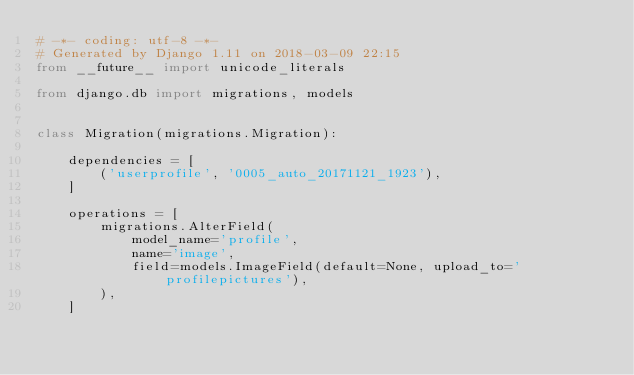Convert code to text. <code><loc_0><loc_0><loc_500><loc_500><_Python_># -*- coding: utf-8 -*-
# Generated by Django 1.11 on 2018-03-09 22:15
from __future__ import unicode_literals

from django.db import migrations, models


class Migration(migrations.Migration):

    dependencies = [
        ('userprofile', '0005_auto_20171121_1923'),
    ]

    operations = [
        migrations.AlterField(
            model_name='profile',
            name='image',
            field=models.ImageField(default=None, upload_to='profilepictures'),
        ),
    ]
</code> 